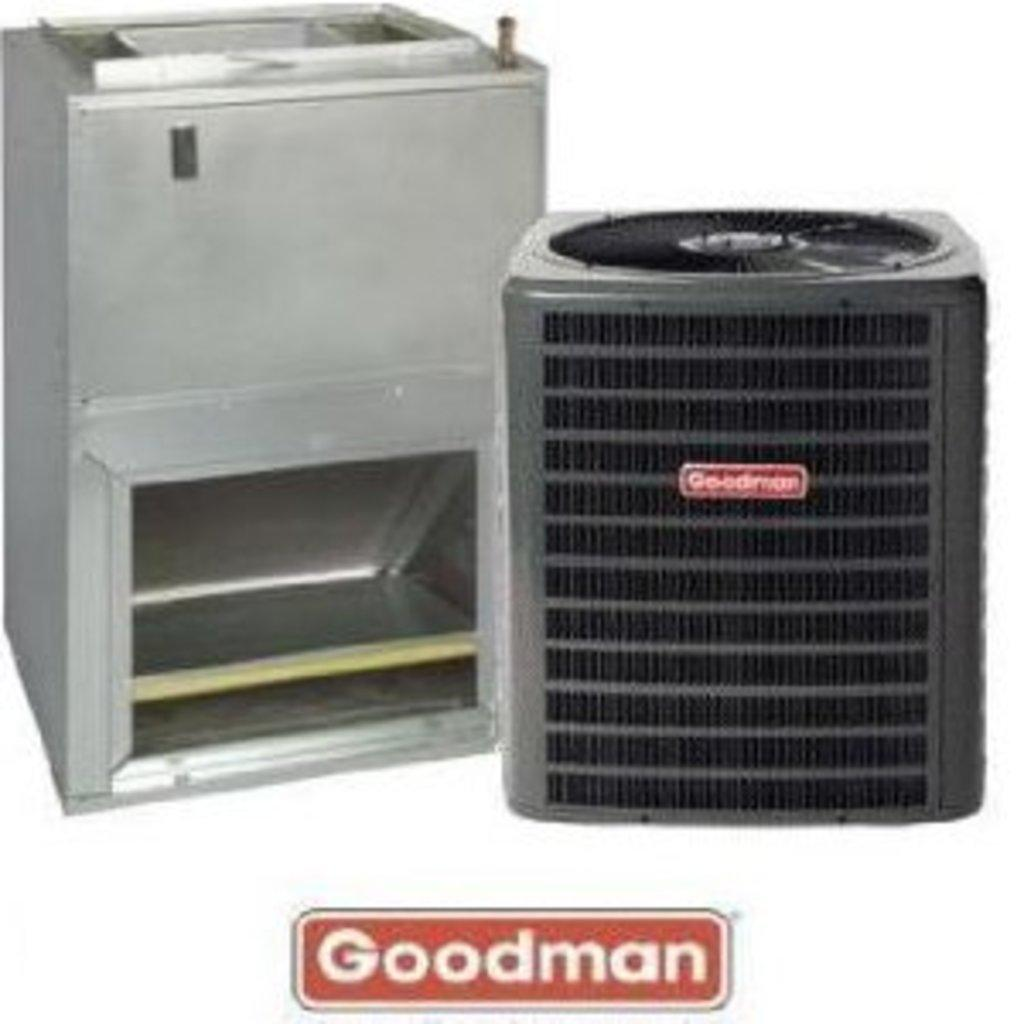<image>
Present a compact description of the photo's key features. An ad for Goodman showing a water fountain and filtration system. 